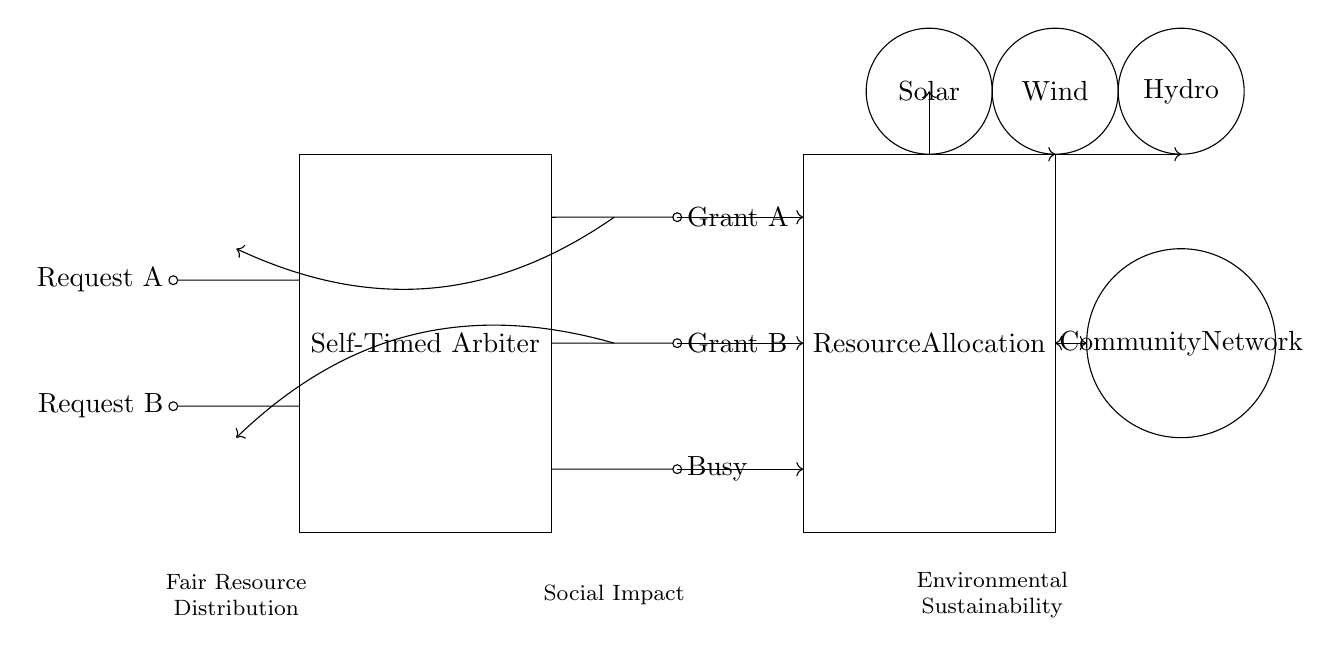What components are included in the self-timed arbiter? The components are Request A, Request B, Grant A, Grant B, and Busy. Each of these components represents signals that interact with the self-timed arbiter block.
Answer: Request A, Request B, Grant A, Grant B, Busy What is the function of the resource allocation block? The resource allocation block is responsible for managing the distribution of resources based on the signals it receives from the self-timed arbiter. It coordinates how resources from renewable sources are allocated to different requests.
Answer: Managing resource distribution How many renewable energy sources are represented in the circuit? There are three renewable energy sources shown in the circuit: Solar, Wind, and Hydro. Each source is depicted as a separate circle indicating its presence in the system.
Answer: Three How does the self-timed arbiter ensure fairness? The self-timed arbiter uses request signals and grants them based on certain conditions without external clocks. This means it can assess concurrent requests and distribute resources fairly over time without bias.
Answer: By assessing requests without bias What ethical consideration is highlighted in the circuit design? The circuit design emphasizes fair resource distribution, which pertains to how energy resources are allocated within the community to ensure equitable access to renewable energy.
Answer: Fair resource distribution What type of network does the community represent? The community represents a community-based network that connects users for shared access to renewable energy resources, emphasizing collective benefits rather than individual ownership.
Answer: Community-based network 